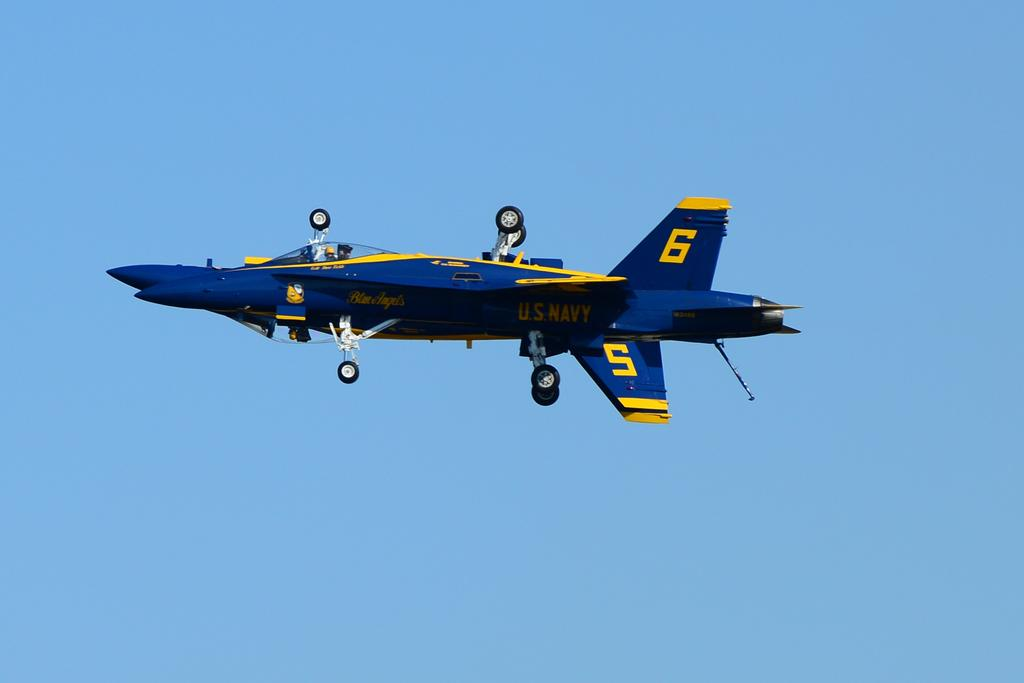<image>
Write a terse but informative summary of the picture. a blue and yellow airplane with 6 and 5 on it 